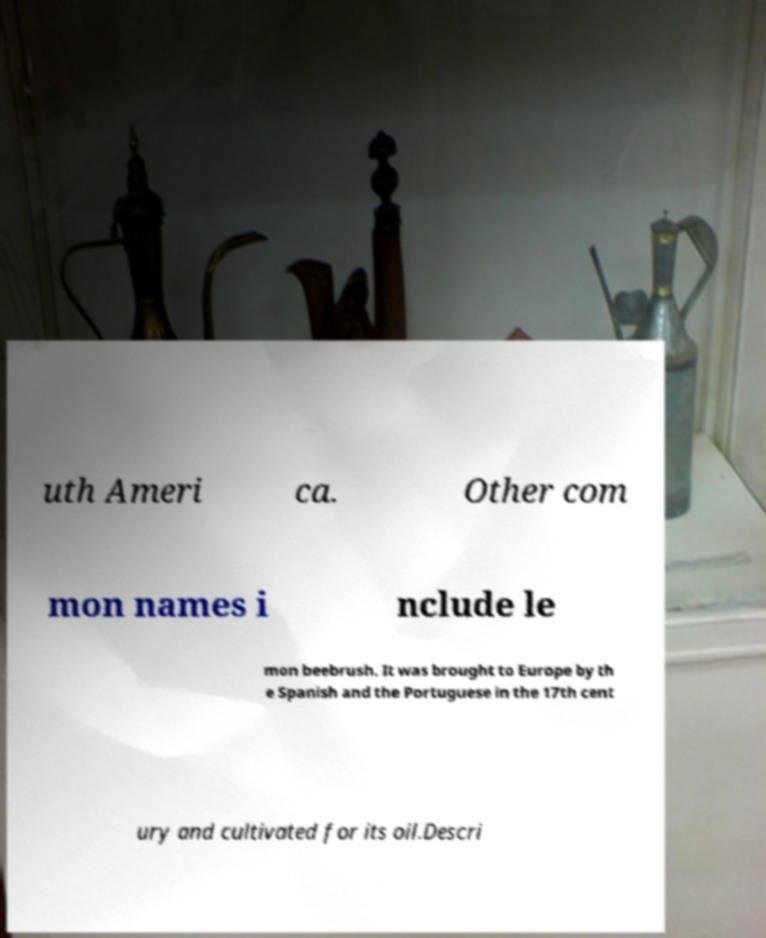Can you accurately transcribe the text from the provided image for me? uth Ameri ca. Other com mon names i nclude le mon beebrush. It was brought to Europe by th e Spanish and the Portuguese in the 17th cent ury and cultivated for its oil.Descri 